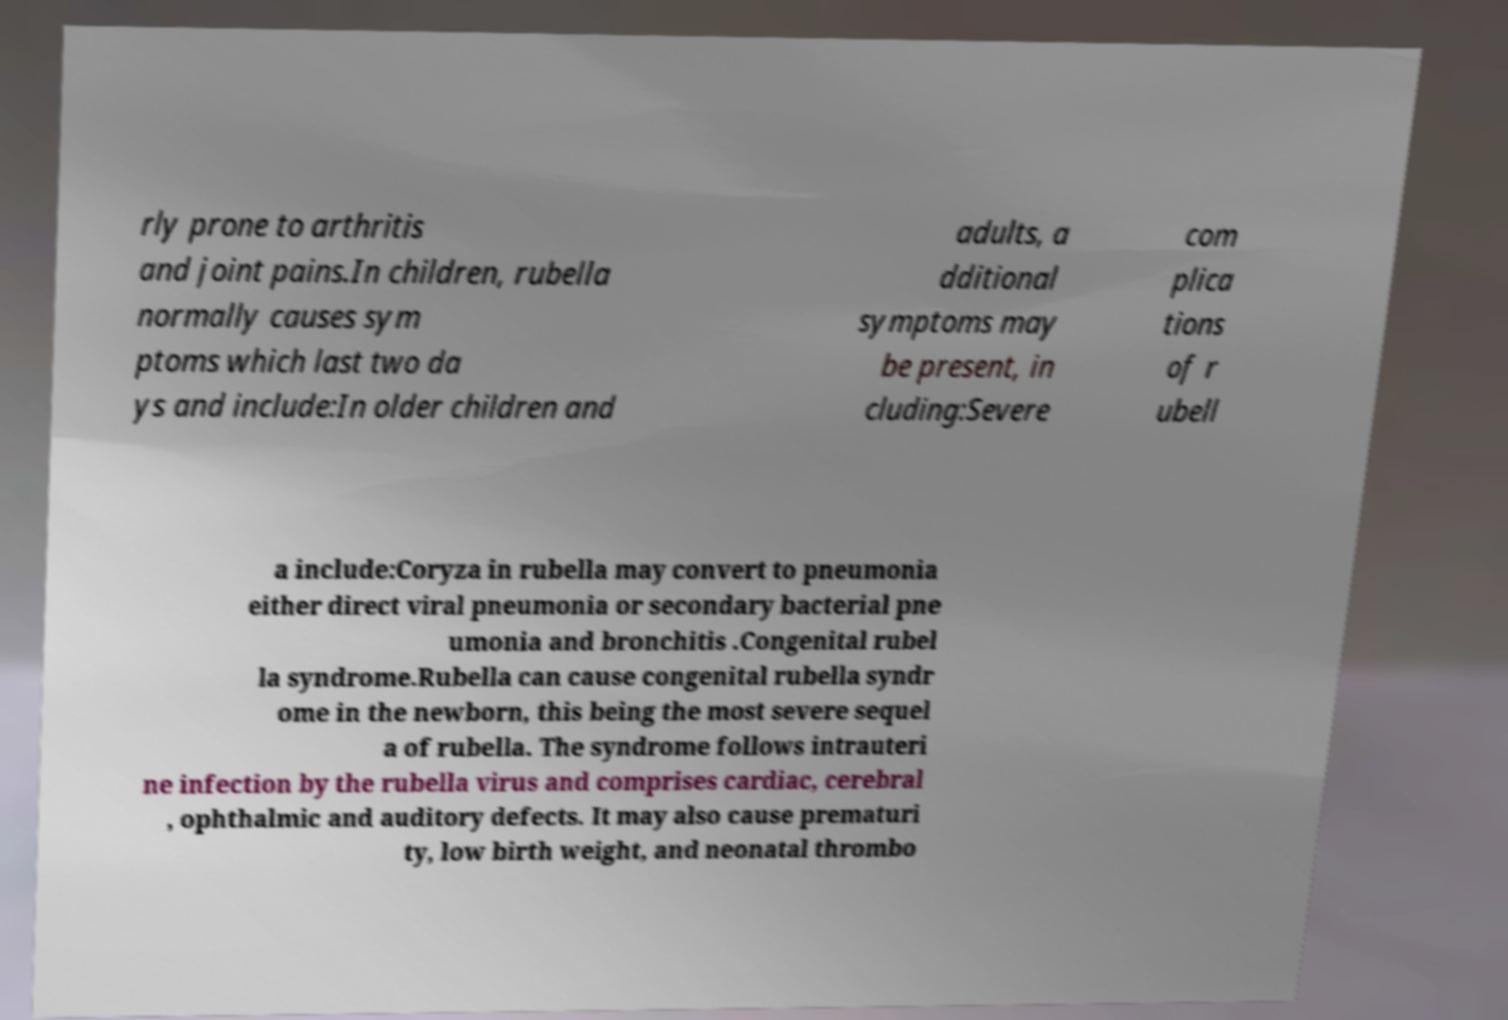I need the written content from this picture converted into text. Can you do that? rly prone to arthritis and joint pains.In children, rubella normally causes sym ptoms which last two da ys and include:In older children and adults, a dditional symptoms may be present, in cluding:Severe com plica tions of r ubell a include:Coryza in rubella may convert to pneumonia either direct viral pneumonia or secondary bacterial pne umonia and bronchitis .Congenital rubel la syndrome.Rubella can cause congenital rubella syndr ome in the newborn, this being the most severe sequel a of rubella. The syndrome follows intrauteri ne infection by the rubella virus and comprises cardiac, cerebral , ophthalmic and auditory defects. It may also cause prematuri ty, low birth weight, and neonatal thrombo 